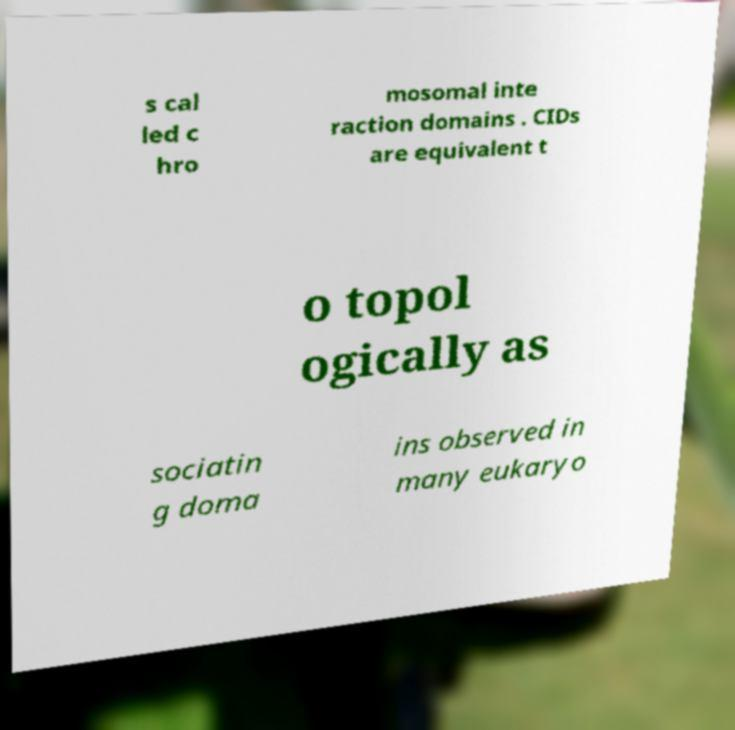I need the written content from this picture converted into text. Can you do that? s cal led c hro mosomal inte raction domains . CIDs are equivalent t o topol ogically as sociatin g doma ins observed in many eukaryo 